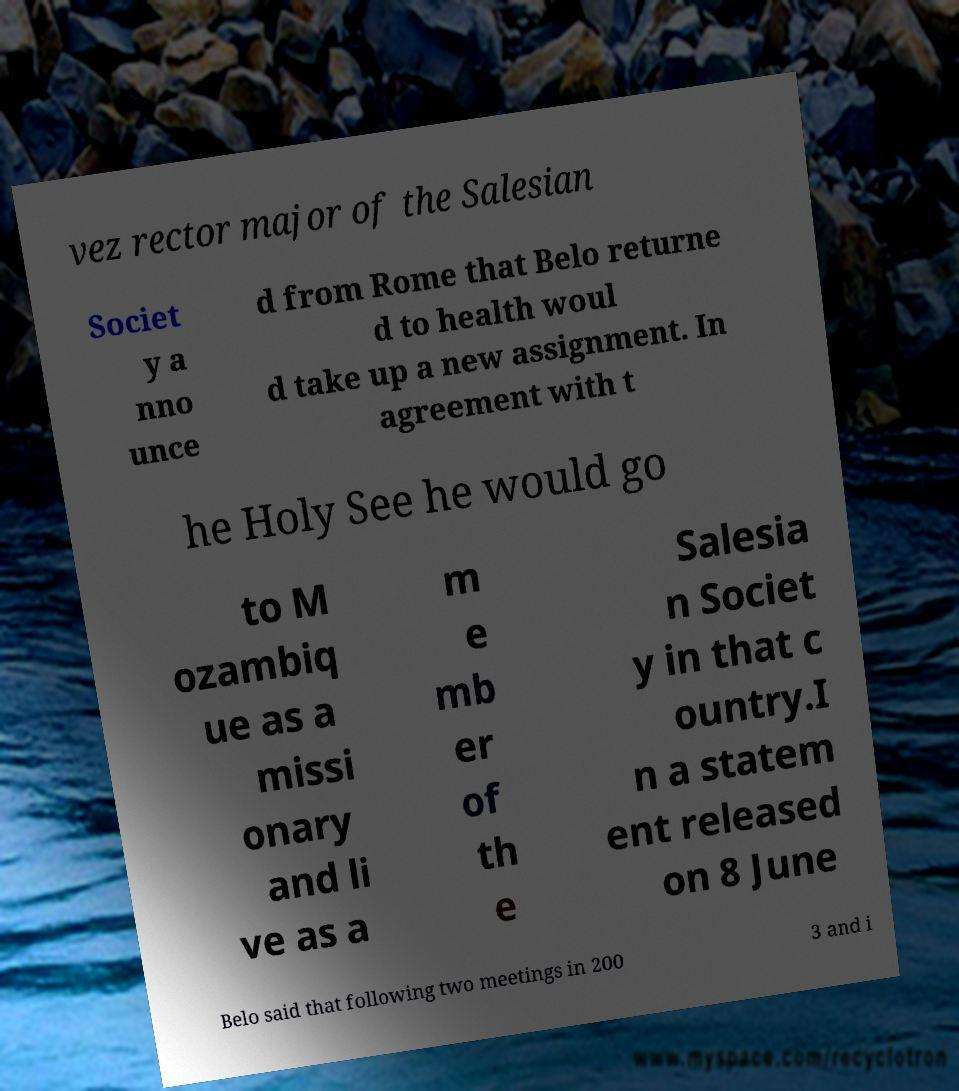Please identify and transcribe the text found in this image. vez rector major of the Salesian Societ y a nno unce d from Rome that Belo returne d to health woul d take up a new assignment. In agreement with t he Holy See he would go to M ozambiq ue as a missi onary and li ve as a m e mb er of th e Salesia n Societ y in that c ountry.I n a statem ent released on 8 June Belo said that following two meetings in 200 3 and i 